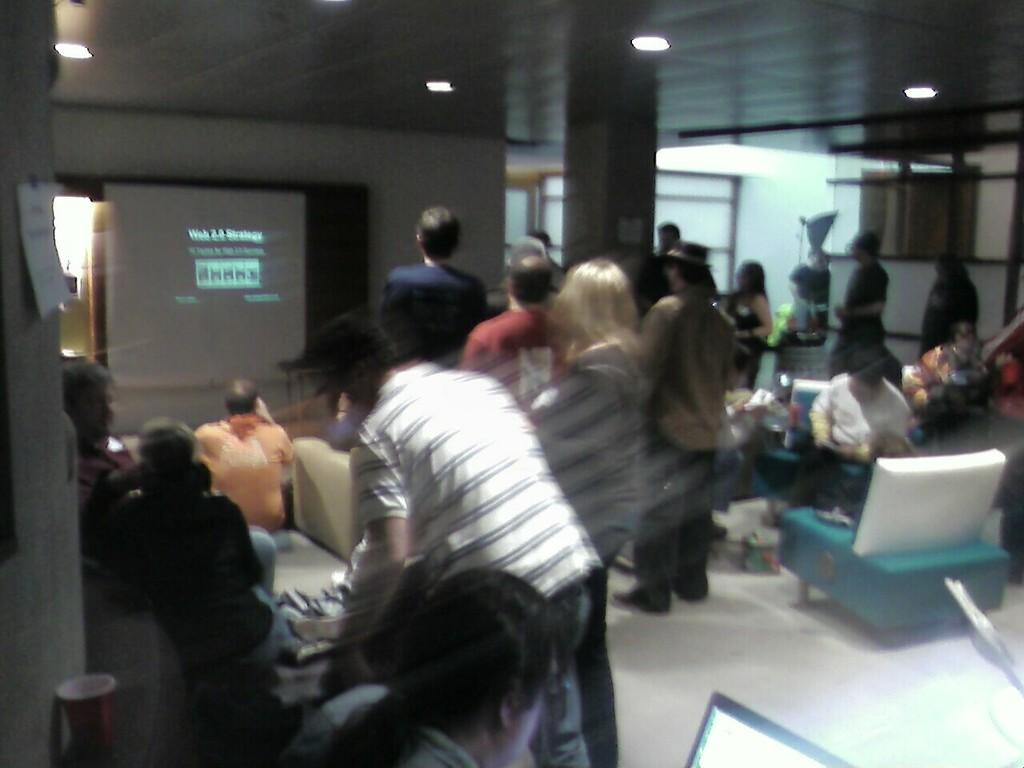How many people are in the image? There are people in the image, but the exact number is not specified. What type of furniture is present in the image? There is a bench in the image. What type of structure is visible in the image? There is a wall in the image. What type of display device is present in the image? There is a screen in the image. What type of illumination is present in the image? There are lights in the image. What type of decoration is present in the image? There is a poster in the image. What type of electronic device is present in the image? There is a laptop in the front of the image. Reasoning: Let' Let's think step by step in order to produce the conversation. We start by identifying the main subjects and objects in the image based on the provided facts. We then formulate questions that focus on the type of each subject or object, ensuring that each question can be answered definitively with the information given. We avoid yes/no questions and ensure that the language is simple and clear. Absurd Question/Answer: What type of drink is being consumed by the people in the image? There is no information about any drinks being consumed in the image. What type of vein is visible on the laptop in the image? There are no veins visible on the laptop in the image; it is an electronic device, not a living organism. What type of digestion is happening in the image? There is no information about digestion in the image, as it does not involve living organisms or their digestive processes. What type of vein is visible on the laptop in the image? There are no veins visible on the laptop in the image; it is an electronic device, not a living organism. 